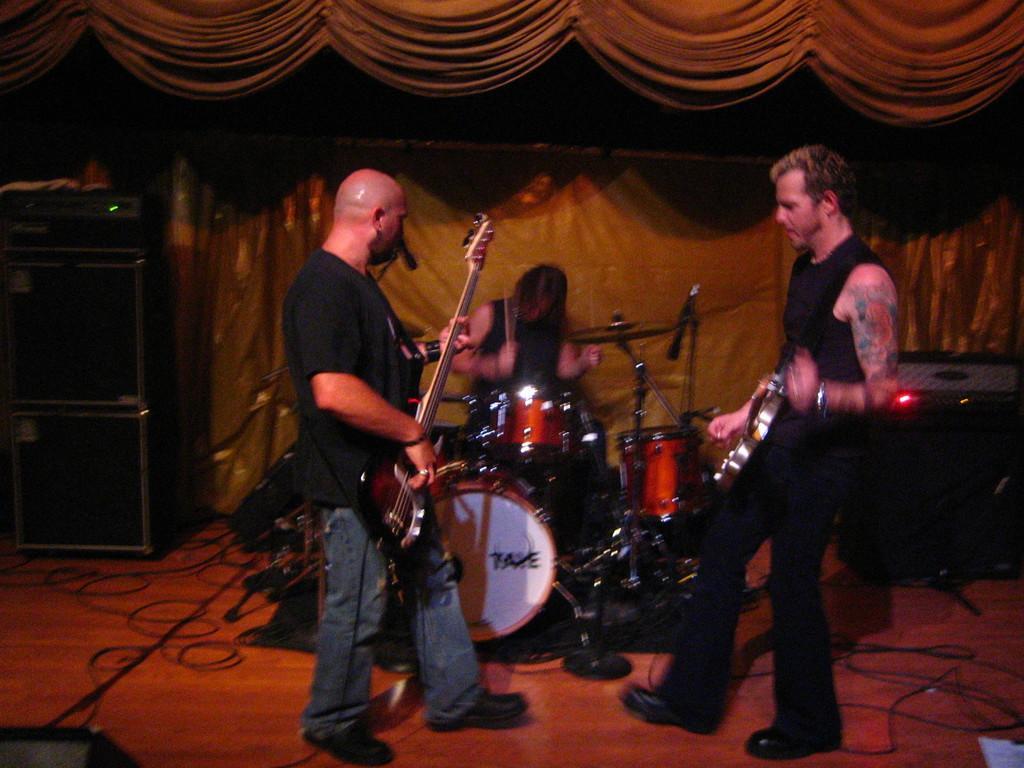Please provide a concise description of this image. In this image, we can see 3 peoples are playing a musical instrument. There is a yellow color background curtain. And top of the image we can also see. Left side and right side, we can see some boxes. At the floor, There are so many wires. 